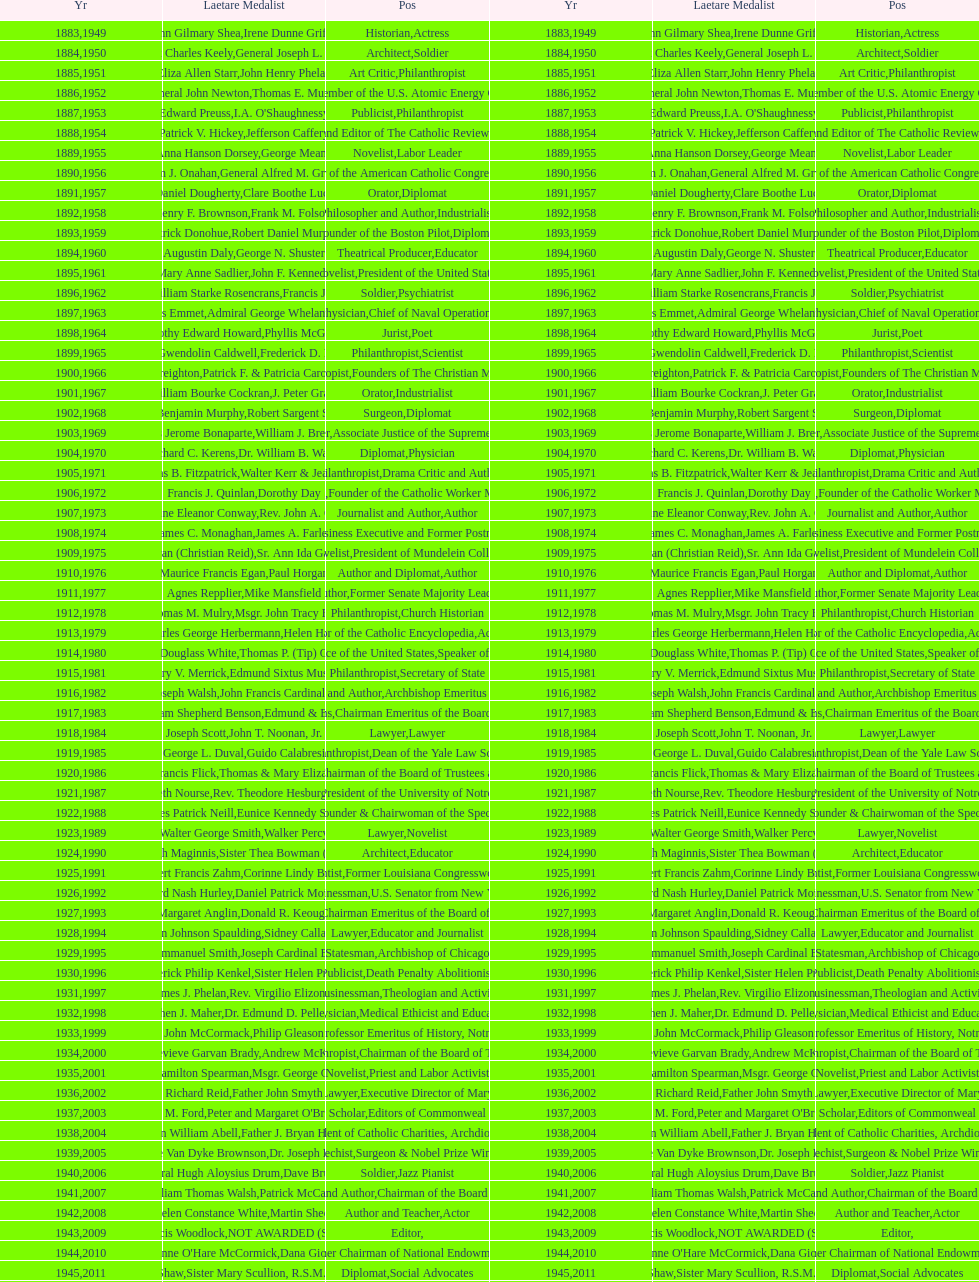How many laetare medalists were philantrohpists? 2. 